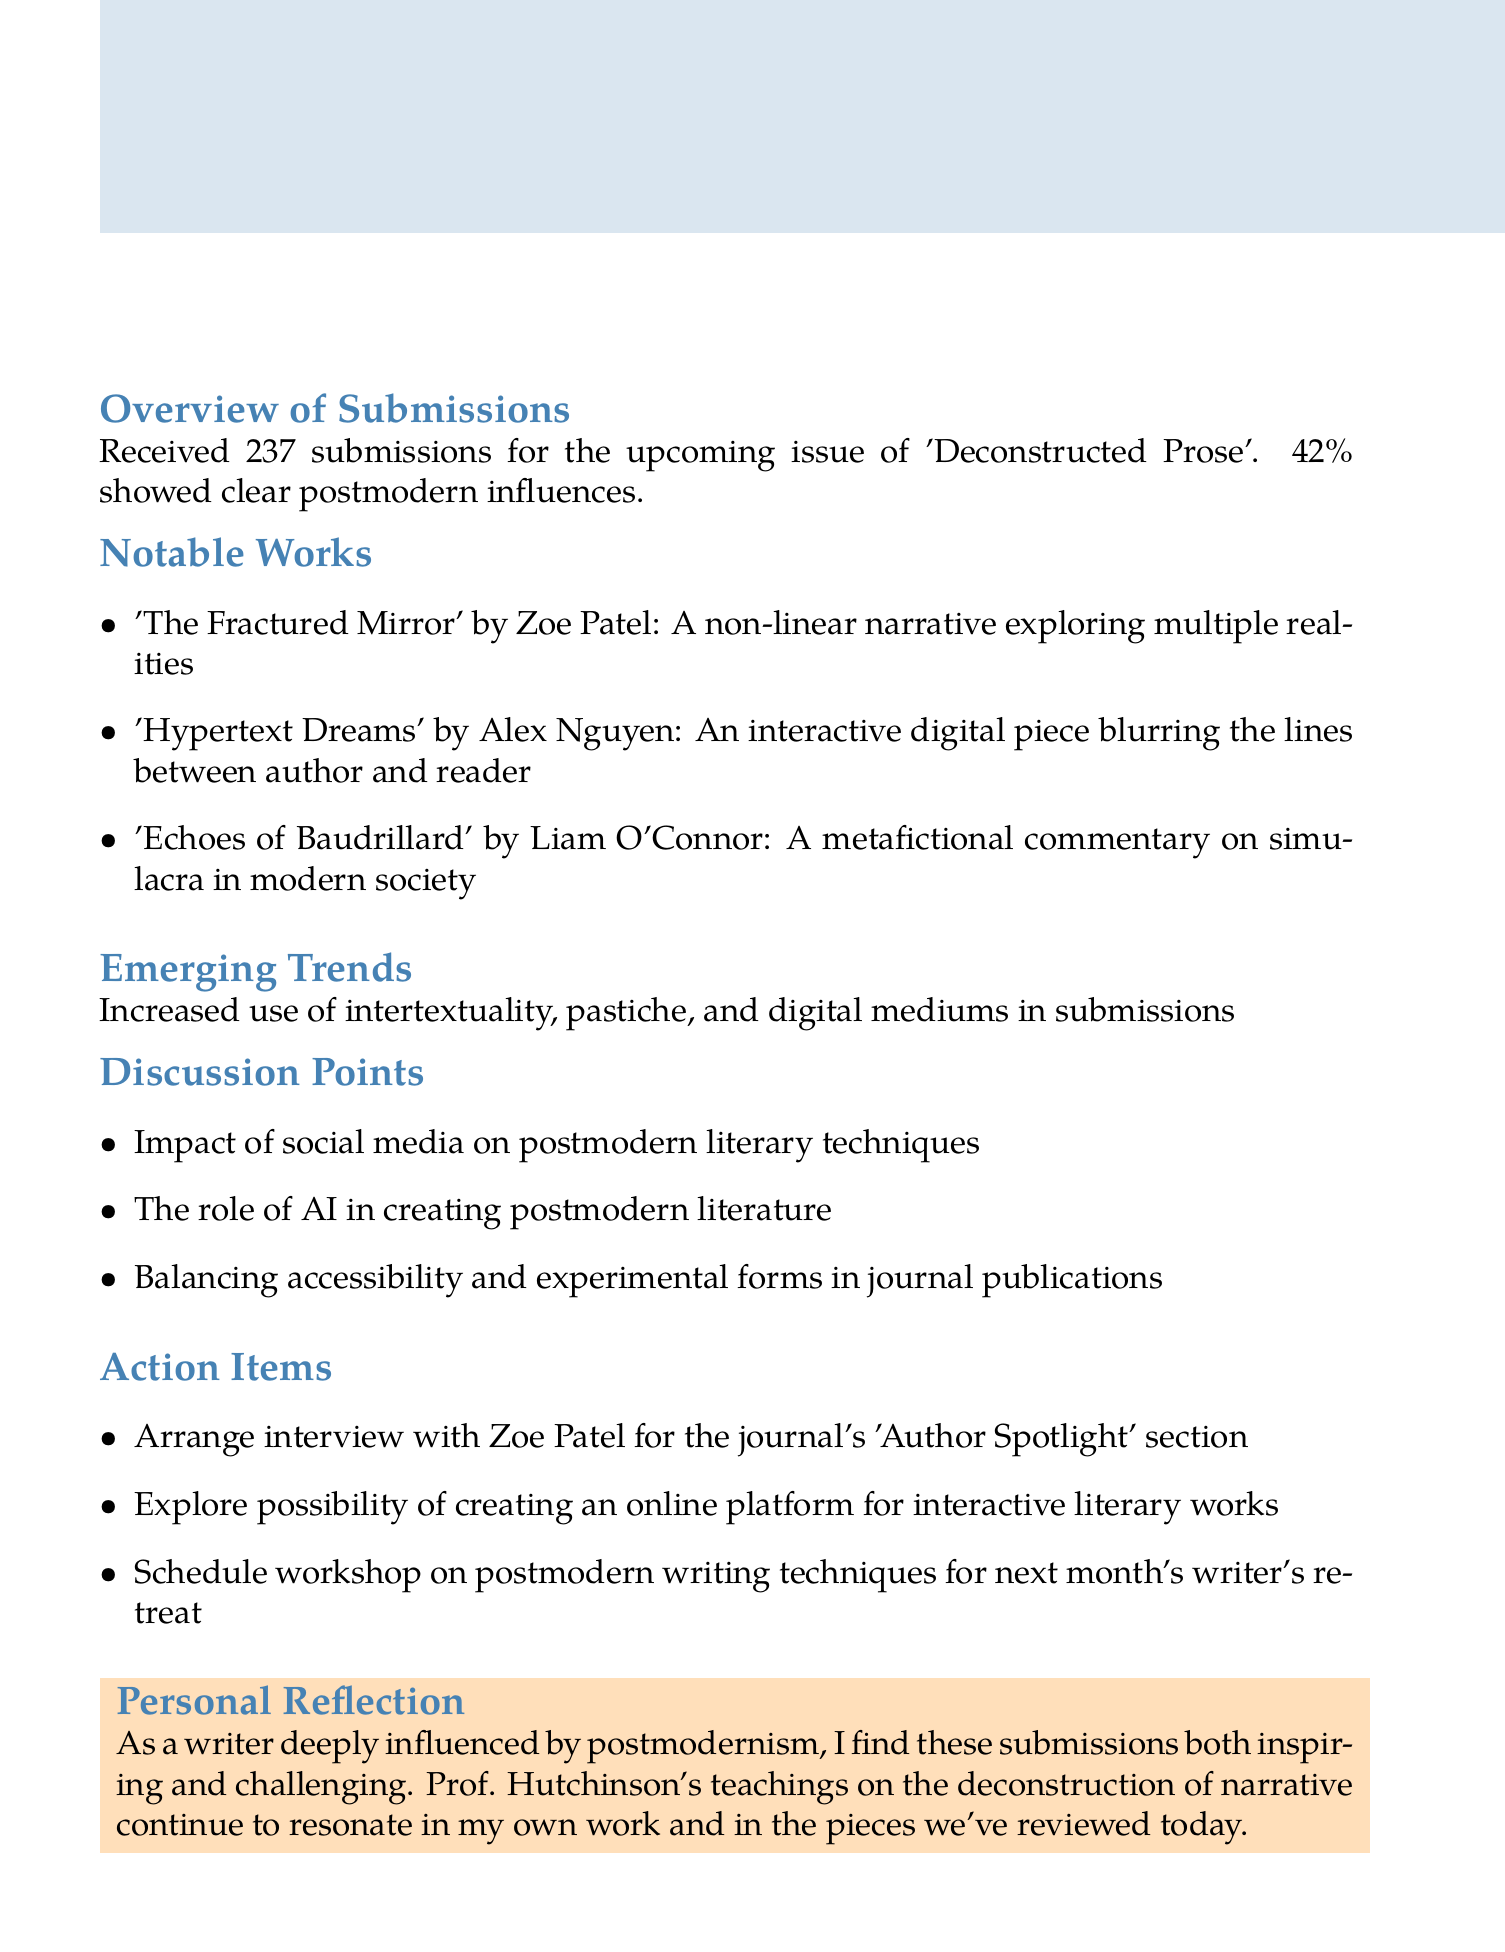What is the title of the meeting? The title of the meeting is found in the header section of the document.
Answer: Analysis of Recent Literary Journal Submissions: Postmodern Influences What date was the meeting held? The date is mentioned directly after the title of the meeting.
Answer: 2023-05-15 How many submissions were received? The number of submissions is specified in the overview section of the document.
Answer: 237 What percentage of submissions showed postmodern influences? The percentage of submissions showing postmodern influences is included in the overview section.
Answer: 42% Who wrote 'Hypertext Dreams'? The author of 'Hypertext Dreams' is listed in the notable works section.
Answer: Alex Nguyen What emerging trend is noted in the submissions? The emerging trend is found in its own section discussing recent characteristics of submissions.
Answer: Increased use of intertextuality, pastiche, and digital mediums Which action item involves an interview? The action items section lists tasks including one related to an interview.
Answer: Arrange interview with Zoe Patel for the journal's 'Author Spotlight' section What is a personal reflection mentioned in the document? The personal reflection is a closing thought in the meeting minutes, reflecting on teachings that resonate with the writer.
Answer: Prof. Hutchinson's teachings on the deconstruction of narrative continue to resonate in my own work and in the pieces we've reviewed today 